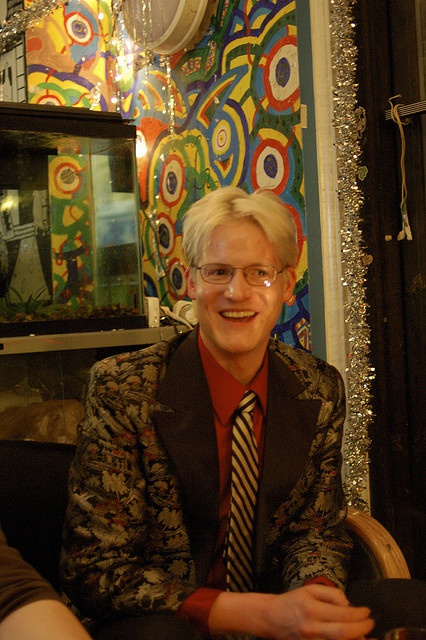Describe the objects in this image and their specific colors. I can see people in olive, black, maroon, and brown tones, bench in olive, black, maroon, and brown tones, tie in olive, black, and maroon tones, and chair in olive, brown, black, and maroon tones in this image. 